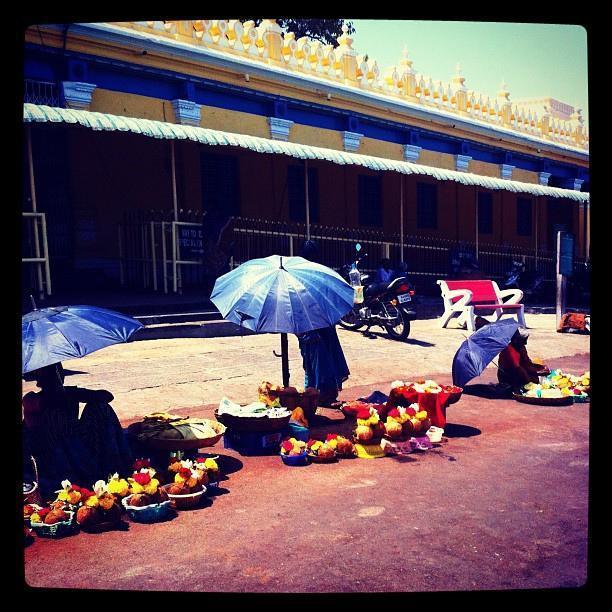How many umbrellas are there?
Give a very brief answer. 3. How many people are in the photo?
Give a very brief answer. 2. How many umbrellas are in the photo?
Give a very brief answer. 3. 